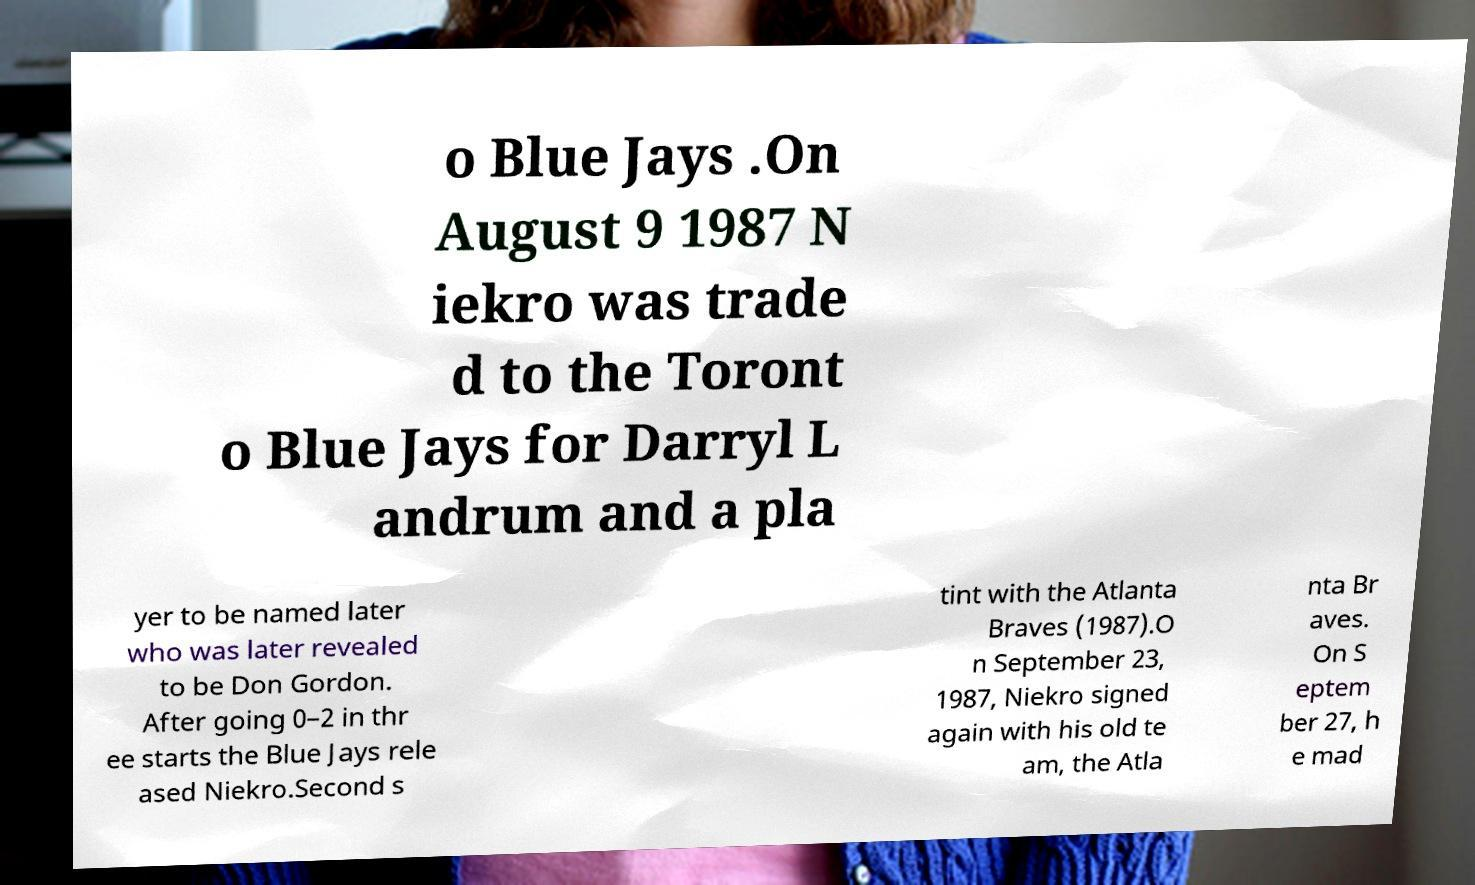I need the written content from this picture converted into text. Can you do that? o Blue Jays .On August 9 1987 N iekro was trade d to the Toront o Blue Jays for Darryl L andrum and a pla yer to be named later who was later revealed to be Don Gordon. After going 0–2 in thr ee starts the Blue Jays rele ased Niekro.Second s tint with the Atlanta Braves (1987).O n September 23, 1987, Niekro signed again with his old te am, the Atla nta Br aves. On S eptem ber 27, h e mad 